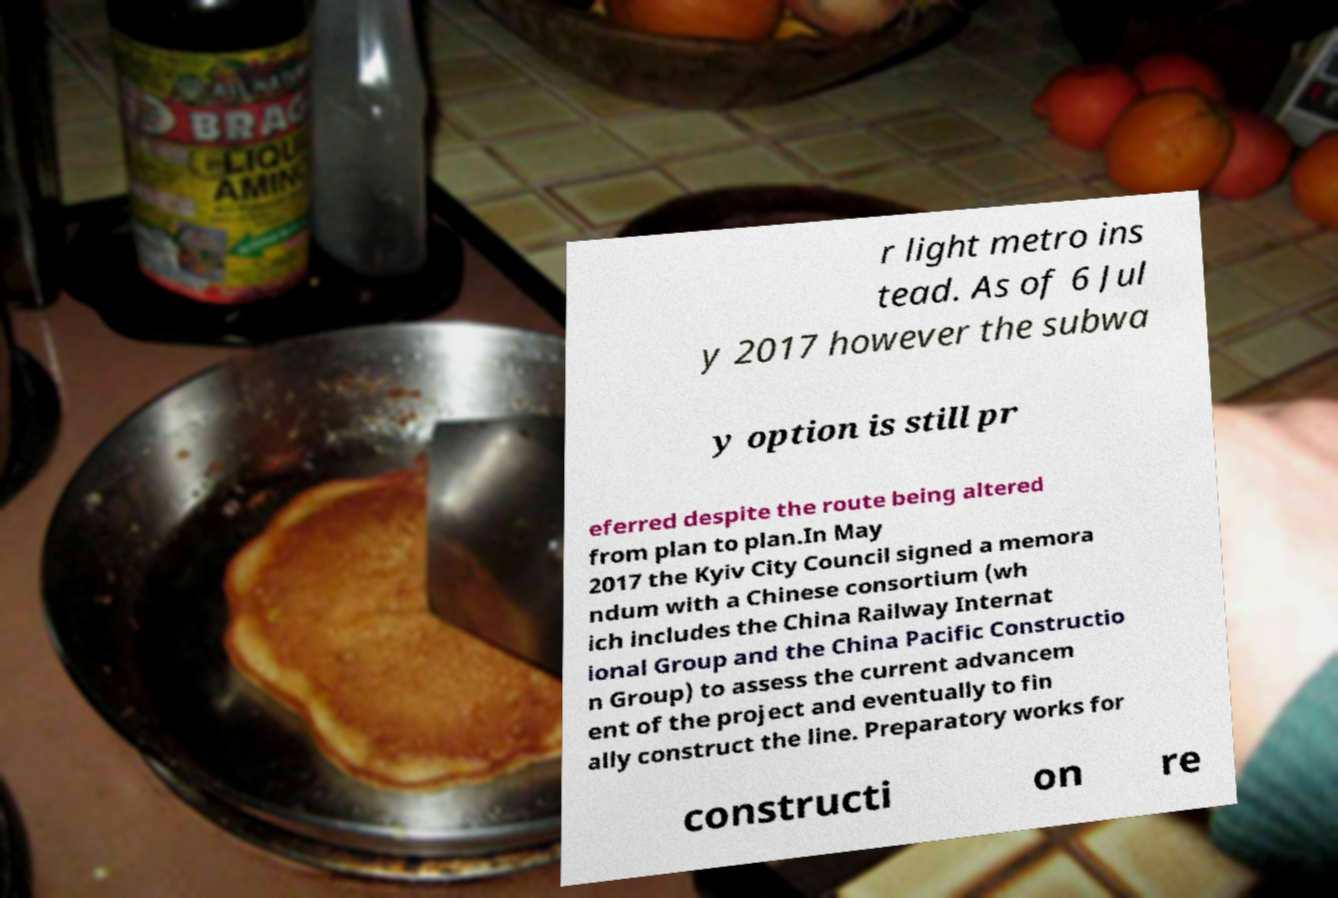Could you extract and type out the text from this image? r light metro ins tead. As of 6 Jul y 2017 however the subwa y option is still pr eferred despite the route being altered from plan to plan.In May 2017 the Kyiv City Council signed a memora ndum with a Chinese consortium (wh ich includes the China Railway Internat ional Group and the China Pacific Constructio n Group) to assess the current advancem ent of the project and eventually to fin ally construct the line. Preparatory works for constructi on re 